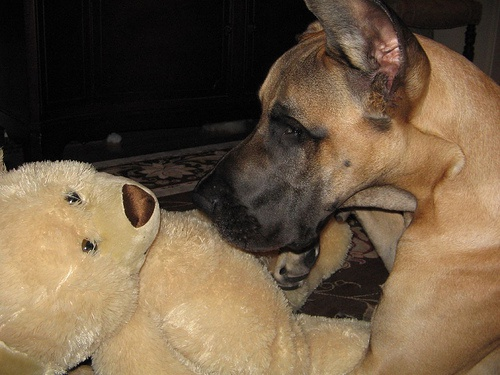Describe the objects in this image and their specific colors. I can see dog in black, tan, gray, and maroon tones and teddy bear in black, tan, and gray tones in this image. 